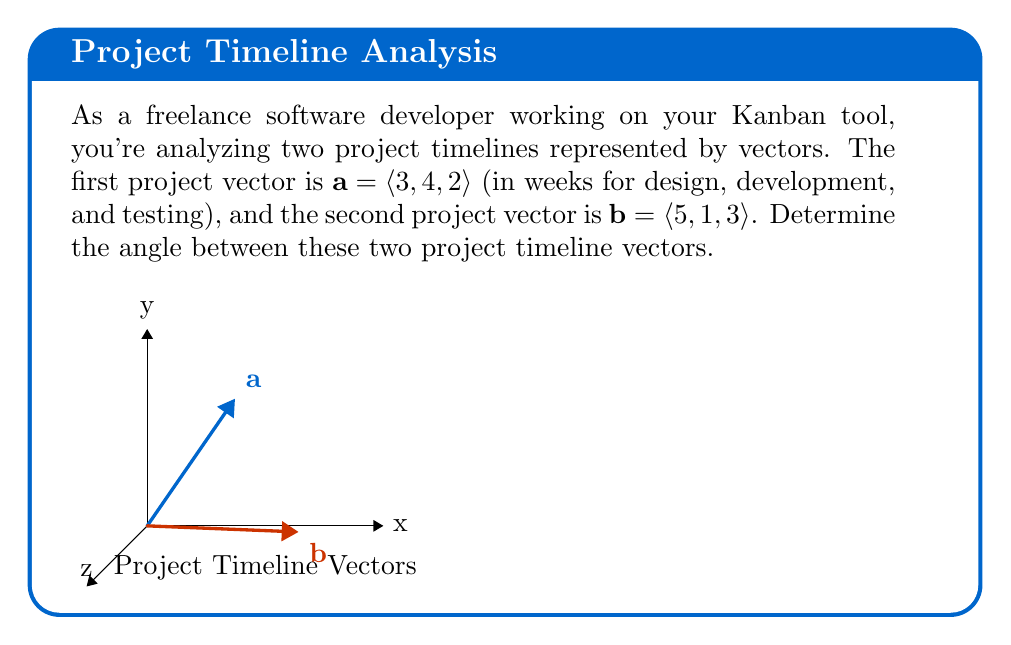Provide a solution to this math problem. To find the angle between two vectors, we can use the dot product formula:

$$\cos \theta = \frac{\mathbf{a} \cdot \mathbf{b}}{|\mathbf{a}||\mathbf{b}|}$$

Let's solve this step-by-step:

1) First, calculate the dot product $\mathbf{a} \cdot \mathbf{b}$:
   $$\mathbf{a} \cdot \mathbf{b} = (3)(5) + (4)(1) + (2)(3) = 15 + 4 + 6 = 25$$

2) Calculate the magnitudes of vectors $\mathbf{a}$ and $\mathbf{b}$:
   $$|\mathbf{a}| = \sqrt{3^2 + 4^2 + 2^2} = \sqrt{9 + 16 + 4} = \sqrt{29}$$
   $$|\mathbf{b}| = \sqrt{5^2 + 1^2 + 3^2} = \sqrt{25 + 1 + 9} = \sqrt{35}$$

3) Now, substitute these values into the formula:
   $$\cos \theta = \frac{25}{\sqrt{29}\sqrt{35}}$$

4) Simplify:
   $$\cos \theta = \frac{25}{\sqrt{1015}}$$

5) To find $\theta$, take the inverse cosine (arccos) of both sides:
   $$\theta = \arccos\left(\frac{25}{\sqrt{1015}}\right)$$

6) Calculate this value (you can use a calculator):
   $$\theta \approx 0.6435 \text{ radians}$$

7) Convert to degrees:
   $$\theta \approx 36.87°$$
Answer: $36.87°$ 